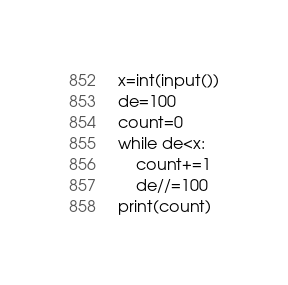<code> <loc_0><loc_0><loc_500><loc_500><_Python_>x=int(input())
de=100
count=0
while de<x:
    count+=1
    de//=100
print(count)</code> 